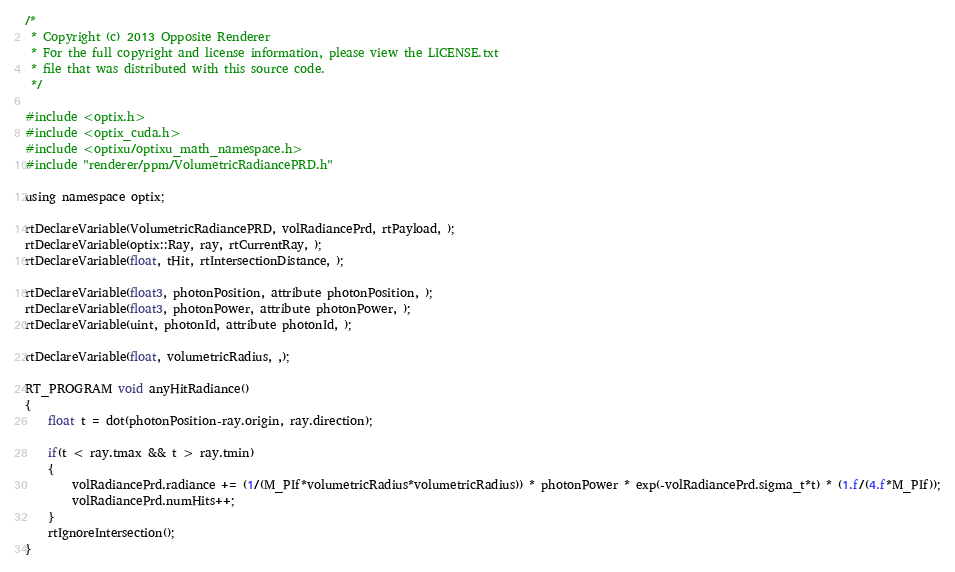<code> <loc_0><loc_0><loc_500><loc_500><_Cuda_>/* 
 * Copyright (c) 2013 Opposite Renderer
 * For the full copyright and license information, please view the LICENSE.txt
 * file that was distributed with this source code.
 */

#include <optix.h>
#include <optix_cuda.h>
#include <optixu/optixu_math_namespace.h>
#include "renderer/ppm/VolumetricRadiancePRD.h"

using namespace optix;

rtDeclareVariable(VolumetricRadiancePRD, volRadiancePrd, rtPayload, );
rtDeclareVariable(optix::Ray, ray, rtCurrentRay, );
rtDeclareVariable(float, tHit, rtIntersectionDistance, );

rtDeclareVariable(float3, photonPosition, attribute photonPosition, ); 
rtDeclareVariable(float3, photonPower, attribute photonPower, ); 
rtDeclareVariable(uint, photonId, attribute photonId, ); 

rtDeclareVariable(float, volumetricRadius, ,); 

RT_PROGRAM void anyHitRadiance()
{
    float t = dot(photonPosition-ray.origin, ray.direction);

    if(t < ray.tmax && t > ray.tmin)
    {
        volRadiancePrd.radiance += (1/(M_PIf*volumetricRadius*volumetricRadius)) * photonPower * exp(-volRadiancePrd.sigma_t*t) * (1.f/(4.f*M_PIf));
        volRadiancePrd.numHits++;
    }
    rtIgnoreIntersection();
}</code> 